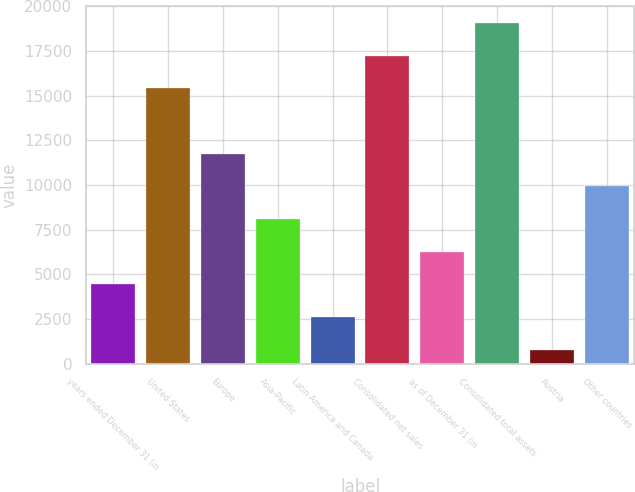<chart> <loc_0><loc_0><loc_500><loc_500><bar_chart><fcel>years ended December 31 (in<fcel>United States<fcel>Europe<fcel>Asia-Pacific<fcel>Latin America and Canada<fcel>Consolidated net sales<fcel>as of December 31 (in<fcel>Consolidated total assets<fcel>Austria<fcel>Other countries<nl><fcel>4443.4<fcel>15415.6<fcel>11758.2<fcel>8100.8<fcel>2614.7<fcel>17244.3<fcel>6272.1<fcel>19073<fcel>786<fcel>9929.5<nl></chart> 